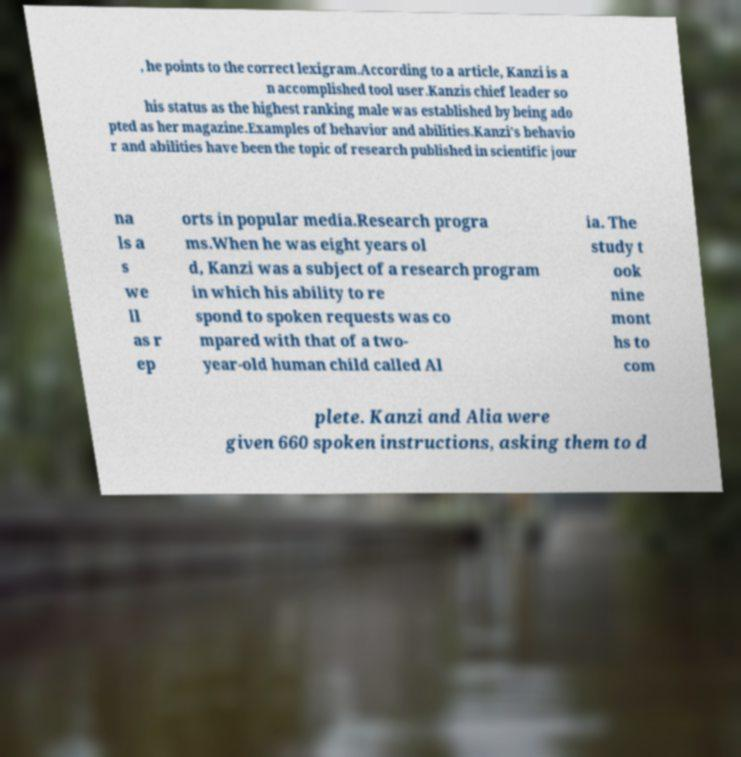What messages or text are displayed in this image? I need them in a readable, typed format. , he points to the correct lexigram.According to a article, Kanzi is a n accomplished tool user.Kanzis chief leader so his status as the highest ranking male was established by being ado pted as her magazine.Examples of behavior and abilities.Kanzi's behavio r and abilities have been the topic of research published in scientific jour na ls a s we ll as r ep orts in popular media.Research progra ms.When he was eight years ol d, Kanzi was a subject of a research program in which his ability to re spond to spoken requests was co mpared with that of a two- year-old human child called Al ia. The study t ook nine mont hs to com plete. Kanzi and Alia were given 660 spoken instructions, asking them to d 